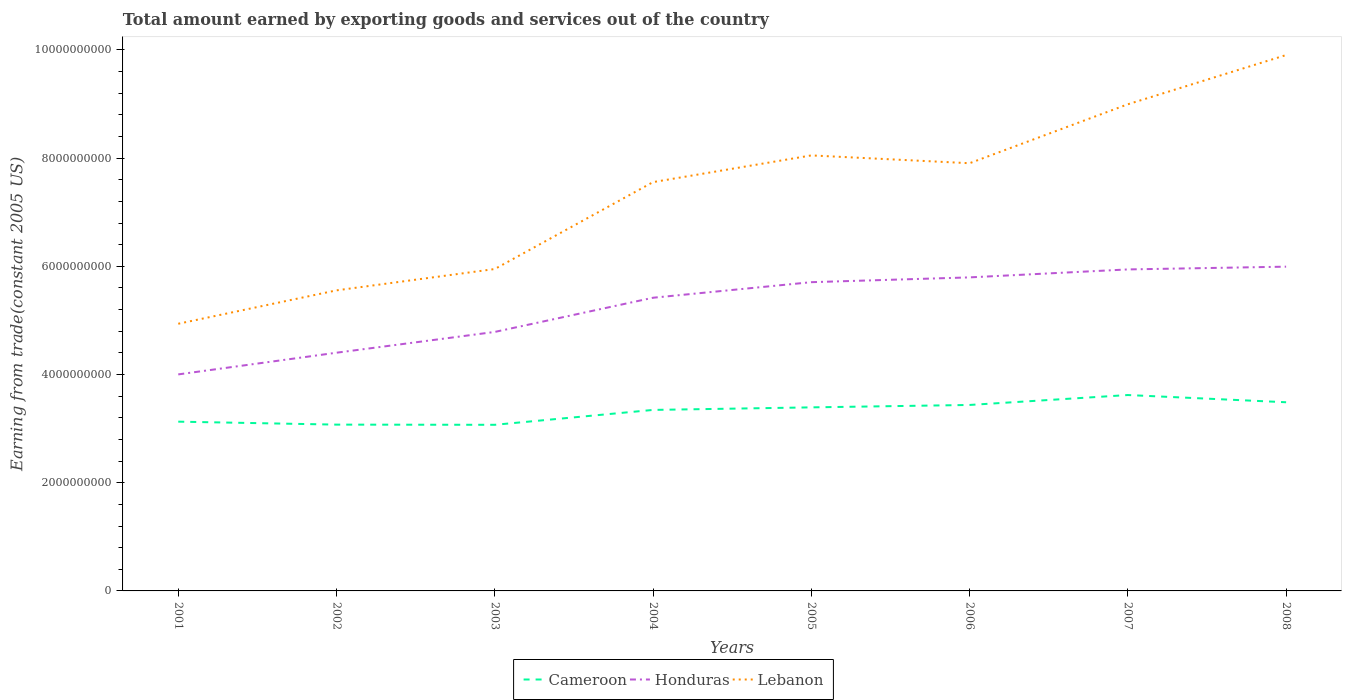Does the line corresponding to Honduras intersect with the line corresponding to Cameroon?
Your answer should be compact. No. Is the number of lines equal to the number of legend labels?
Give a very brief answer. Yes. Across all years, what is the maximum total amount earned by exporting goods and services in Cameroon?
Provide a short and direct response. 3.07e+09. What is the total total amount earned by exporting goods and services in Cameroon in the graph?
Your answer should be compact. -5.47e+08. What is the difference between the highest and the second highest total amount earned by exporting goods and services in Lebanon?
Provide a succinct answer. 4.97e+09. What is the difference between the highest and the lowest total amount earned by exporting goods and services in Honduras?
Offer a terse response. 5. Is the total amount earned by exporting goods and services in Lebanon strictly greater than the total amount earned by exporting goods and services in Honduras over the years?
Ensure brevity in your answer.  No. How many lines are there?
Offer a very short reply. 3. How many years are there in the graph?
Your answer should be compact. 8. Where does the legend appear in the graph?
Your answer should be compact. Bottom center. How are the legend labels stacked?
Your response must be concise. Horizontal. What is the title of the graph?
Provide a short and direct response. Total amount earned by exporting goods and services out of the country. What is the label or title of the X-axis?
Your answer should be compact. Years. What is the label or title of the Y-axis?
Make the answer very short. Earning from trade(constant 2005 US). What is the Earning from trade(constant 2005 US) in Cameroon in 2001?
Offer a terse response. 3.13e+09. What is the Earning from trade(constant 2005 US) of Honduras in 2001?
Keep it short and to the point. 4.00e+09. What is the Earning from trade(constant 2005 US) in Lebanon in 2001?
Ensure brevity in your answer.  4.94e+09. What is the Earning from trade(constant 2005 US) in Cameroon in 2002?
Your response must be concise. 3.07e+09. What is the Earning from trade(constant 2005 US) of Honduras in 2002?
Make the answer very short. 4.40e+09. What is the Earning from trade(constant 2005 US) in Lebanon in 2002?
Offer a very short reply. 5.56e+09. What is the Earning from trade(constant 2005 US) of Cameroon in 2003?
Your response must be concise. 3.07e+09. What is the Earning from trade(constant 2005 US) in Honduras in 2003?
Provide a short and direct response. 4.79e+09. What is the Earning from trade(constant 2005 US) of Lebanon in 2003?
Your response must be concise. 5.95e+09. What is the Earning from trade(constant 2005 US) of Cameroon in 2004?
Provide a short and direct response. 3.35e+09. What is the Earning from trade(constant 2005 US) of Honduras in 2004?
Your answer should be very brief. 5.42e+09. What is the Earning from trade(constant 2005 US) in Lebanon in 2004?
Your answer should be very brief. 7.56e+09. What is the Earning from trade(constant 2005 US) of Cameroon in 2005?
Ensure brevity in your answer.  3.39e+09. What is the Earning from trade(constant 2005 US) of Honduras in 2005?
Offer a terse response. 5.71e+09. What is the Earning from trade(constant 2005 US) in Lebanon in 2005?
Provide a short and direct response. 8.05e+09. What is the Earning from trade(constant 2005 US) in Cameroon in 2006?
Make the answer very short. 3.44e+09. What is the Earning from trade(constant 2005 US) of Honduras in 2006?
Ensure brevity in your answer.  5.80e+09. What is the Earning from trade(constant 2005 US) of Lebanon in 2006?
Give a very brief answer. 7.91e+09. What is the Earning from trade(constant 2005 US) of Cameroon in 2007?
Provide a succinct answer. 3.62e+09. What is the Earning from trade(constant 2005 US) in Honduras in 2007?
Your answer should be very brief. 5.94e+09. What is the Earning from trade(constant 2005 US) in Lebanon in 2007?
Your answer should be compact. 9.00e+09. What is the Earning from trade(constant 2005 US) of Cameroon in 2008?
Your answer should be compact. 3.49e+09. What is the Earning from trade(constant 2005 US) in Honduras in 2008?
Ensure brevity in your answer.  5.99e+09. What is the Earning from trade(constant 2005 US) of Lebanon in 2008?
Your answer should be compact. 9.91e+09. Across all years, what is the maximum Earning from trade(constant 2005 US) of Cameroon?
Provide a succinct answer. 3.62e+09. Across all years, what is the maximum Earning from trade(constant 2005 US) of Honduras?
Your response must be concise. 5.99e+09. Across all years, what is the maximum Earning from trade(constant 2005 US) of Lebanon?
Offer a terse response. 9.91e+09. Across all years, what is the minimum Earning from trade(constant 2005 US) in Cameroon?
Your answer should be very brief. 3.07e+09. Across all years, what is the minimum Earning from trade(constant 2005 US) in Honduras?
Your response must be concise. 4.00e+09. Across all years, what is the minimum Earning from trade(constant 2005 US) of Lebanon?
Offer a very short reply. 4.94e+09. What is the total Earning from trade(constant 2005 US) of Cameroon in the graph?
Provide a succinct answer. 2.66e+1. What is the total Earning from trade(constant 2005 US) in Honduras in the graph?
Offer a terse response. 4.21e+1. What is the total Earning from trade(constant 2005 US) in Lebanon in the graph?
Your answer should be compact. 5.89e+1. What is the difference between the Earning from trade(constant 2005 US) of Cameroon in 2001 and that in 2002?
Provide a succinct answer. 5.49e+07. What is the difference between the Earning from trade(constant 2005 US) in Honduras in 2001 and that in 2002?
Keep it short and to the point. -4.01e+08. What is the difference between the Earning from trade(constant 2005 US) in Lebanon in 2001 and that in 2002?
Offer a very short reply. -6.17e+08. What is the difference between the Earning from trade(constant 2005 US) of Cameroon in 2001 and that in 2003?
Your answer should be very brief. 5.82e+07. What is the difference between the Earning from trade(constant 2005 US) in Honduras in 2001 and that in 2003?
Your answer should be very brief. -7.85e+08. What is the difference between the Earning from trade(constant 2005 US) of Lebanon in 2001 and that in 2003?
Your answer should be very brief. -1.01e+09. What is the difference between the Earning from trade(constant 2005 US) in Cameroon in 2001 and that in 2004?
Provide a short and direct response. -2.17e+08. What is the difference between the Earning from trade(constant 2005 US) of Honduras in 2001 and that in 2004?
Your response must be concise. -1.42e+09. What is the difference between the Earning from trade(constant 2005 US) of Lebanon in 2001 and that in 2004?
Your response must be concise. -2.62e+09. What is the difference between the Earning from trade(constant 2005 US) of Cameroon in 2001 and that in 2005?
Provide a short and direct response. -2.64e+08. What is the difference between the Earning from trade(constant 2005 US) in Honduras in 2001 and that in 2005?
Ensure brevity in your answer.  -1.70e+09. What is the difference between the Earning from trade(constant 2005 US) in Lebanon in 2001 and that in 2005?
Keep it short and to the point. -3.11e+09. What is the difference between the Earning from trade(constant 2005 US) in Cameroon in 2001 and that in 2006?
Your response must be concise. -3.09e+08. What is the difference between the Earning from trade(constant 2005 US) in Honduras in 2001 and that in 2006?
Keep it short and to the point. -1.79e+09. What is the difference between the Earning from trade(constant 2005 US) of Lebanon in 2001 and that in 2006?
Give a very brief answer. -2.97e+09. What is the difference between the Earning from trade(constant 2005 US) in Cameroon in 2001 and that in 2007?
Your answer should be compact. -4.92e+08. What is the difference between the Earning from trade(constant 2005 US) in Honduras in 2001 and that in 2007?
Make the answer very short. -1.94e+09. What is the difference between the Earning from trade(constant 2005 US) of Lebanon in 2001 and that in 2007?
Offer a terse response. -4.06e+09. What is the difference between the Earning from trade(constant 2005 US) in Cameroon in 2001 and that in 2008?
Keep it short and to the point. -3.59e+08. What is the difference between the Earning from trade(constant 2005 US) in Honduras in 2001 and that in 2008?
Your answer should be very brief. -1.99e+09. What is the difference between the Earning from trade(constant 2005 US) of Lebanon in 2001 and that in 2008?
Provide a short and direct response. -4.97e+09. What is the difference between the Earning from trade(constant 2005 US) in Cameroon in 2002 and that in 2003?
Ensure brevity in your answer.  3.32e+06. What is the difference between the Earning from trade(constant 2005 US) in Honduras in 2002 and that in 2003?
Give a very brief answer. -3.84e+08. What is the difference between the Earning from trade(constant 2005 US) of Lebanon in 2002 and that in 2003?
Your response must be concise. -3.94e+08. What is the difference between the Earning from trade(constant 2005 US) of Cameroon in 2002 and that in 2004?
Provide a short and direct response. -2.72e+08. What is the difference between the Earning from trade(constant 2005 US) of Honduras in 2002 and that in 2004?
Your response must be concise. -1.02e+09. What is the difference between the Earning from trade(constant 2005 US) in Lebanon in 2002 and that in 2004?
Keep it short and to the point. -2.00e+09. What is the difference between the Earning from trade(constant 2005 US) in Cameroon in 2002 and that in 2005?
Make the answer very short. -3.19e+08. What is the difference between the Earning from trade(constant 2005 US) in Honduras in 2002 and that in 2005?
Keep it short and to the point. -1.30e+09. What is the difference between the Earning from trade(constant 2005 US) in Lebanon in 2002 and that in 2005?
Ensure brevity in your answer.  -2.49e+09. What is the difference between the Earning from trade(constant 2005 US) of Cameroon in 2002 and that in 2006?
Give a very brief answer. -3.63e+08. What is the difference between the Earning from trade(constant 2005 US) of Honduras in 2002 and that in 2006?
Offer a very short reply. -1.39e+09. What is the difference between the Earning from trade(constant 2005 US) in Lebanon in 2002 and that in 2006?
Your response must be concise. -2.35e+09. What is the difference between the Earning from trade(constant 2005 US) in Cameroon in 2002 and that in 2007?
Your response must be concise. -5.47e+08. What is the difference between the Earning from trade(constant 2005 US) in Honduras in 2002 and that in 2007?
Your response must be concise. -1.54e+09. What is the difference between the Earning from trade(constant 2005 US) in Lebanon in 2002 and that in 2007?
Provide a short and direct response. -3.44e+09. What is the difference between the Earning from trade(constant 2005 US) of Cameroon in 2002 and that in 2008?
Offer a very short reply. -4.13e+08. What is the difference between the Earning from trade(constant 2005 US) of Honduras in 2002 and that in 2008?
Your answer should be very brief. -1.59e+09. What is the difference between the Earning from trade(constant 2005 US) of Lebanon in 2002 and that in 2008?
Make the answer very short. -4.35e+09. What is the difference between the Earning from trade(constant 2005 US) in Cameroon in 2003 and that in 2004?
Your answer should be compact. -2.75e+08. What is the difference between the Earning from trade(constant 2005 US) of Honduras in 2003 and that in 2004?
Ensure brevity in your answer.  -6.32e+08. What is the difference between the Earning from trade(constant 2005 US) in Lebanon in 2003 and that in 2004?
Your answer should be very brief. -1.61e+09. What is the difference between the Earning from trade(constant 2005 US) in Cameroon in 2003 and that in 2005?
Provide a succinct answer. -3.22e+08. What is the difference between the Earning from trade(constant 2005 US) in Honduras in 2003 and that in 2005?
Offer a terse response. -9.20e+08. What is the difference between the Earning from trade(constant 2005 US) in Lebanon in 2003 and that in 2005?
Offer a very short reply. -2.10e+09. What is the difference between the Earning from trade(constant 2005 US) in Cameroon in 2003 and that in 2006?
Your answer should be very brief. -3.67e+08. What is the difference between the Earning from trade(constant 2005 US) of Honduras in 2003 and that in 2006?
Offer a terse response. -1.01e+09. What is the difference between the Earning from trade(constant 2005 US) in Lebanon in 2003 and that in 2006?
Provide a short and direct response. -1.96e+09. What is the difference between the Earning from trade(constant 2005 US) in Cameroon in 2003 and that in 2007?
Make the answer very short. -5.50e+08. What is the difference between the Earning from trade(constant 2005 US) in Honduras in 2003 and that in 2007?
Offer a very short reply. -1.16e+09. What is the difference between the Earning from trade(constant 2005 US) in Lebanon in 2003 and that in 2007?
Provide a succinct answer. -3.05e+09. What is the difference between the Earning from trade(constant 2005 US) in Cameroon in 2003 and that in 2008?
Make the answer very short. -4.17e+08. What is the difference between the Earning from trade(constant 2005 US) of Honduras in 2003 and that in 2008?
Provide a succinct answer. -1.21e+09. What is the difference between the Earning from trade(constant 2005 US) of Lebanon in 2003 and that in 2008?
Provide a short and direct response. -3.95e+09. What is the difference between the Earning from trade(constant 2005 US) of Cameroon in 2004 and that in 2005?
Provide a short and direct response. -4.72e+07. What is the difference between the Earning from trade(constant 2005 US) of Honduras in 2004 and that in 2005?
Make the answer very short. -2.88e+08. What is the difference between the Earning from trade(constant 2005 US) of Lebanon in 2004 and that in 2005?
Offer a very short reply. -4.93e+08. What is the difference between the Earning from trade(constant 2005 US) of Cameroon in 2004 and that in 2006?
Provide a succinct answer. -9.17e+07. What is the difference between the Earning from trade(constant 2005 US) in Honduras in 2004 and that in 2006?
Make the answer very short. -3.76e+08. What is the difference between the Earning from trade(constant 2005 US) of Lebanon in 2004 and that in 2006?
Provide a short and direct response. -3.49e+08. What is the difference between the Earning from trade(constant 2005 US) in Cameroon in 2004 and that in 2007?
Your response must be concise. -2.75e+08. What is the difference between the Earning from trade(constant 2005 US) in Honduras in 2004 and that in 2007?
Give a very brief answer. -5.23e+08. What is the difference between the Earning from trade(constant 2005 US) of Lebanon in 2004 and that in 2007?
Make the answer very short. -1.44e+09. What is the difference between the Earning from trade(constant 2005 US) in Cameroon in 2004 and that in 2008?
Offer a terse response. -1.42e+08. What is the difference between the Earning from trade(constant 2005 US) of Honduras in 2004 and that in 2008?
Ensure brevity in your answer.  -5.74e+08. What is the difference between the Earning from trade(constant 2005 US) in Lebanon in 2004 and that in 2008?
Provide a short and direct response. -2.35e+09. What is the difference between the Earning from trade(constant 2005 US) in Cameroon in 2005 and that in 2006?
Ensure brevity in your answer.  -4.46e+07. What is the difference between the Earning from trade(constant 2005 US) of Honduras in 2005 and that in 2006?
Ensure brevity in your answer.  -8.87e+07. What is the difference between the Earning from trade(constant 2005 US) in Lebanon in 2005 and that in 2006?
Offer a very short reply. 1.44e+08. What is the difference between the Earning from trade(constant 2005 US) of Cameroon in 2005 and that in 2007?
Offer a very short reply. -2.28e+08. What is the difference between the Earning from trade(constant 2005 US) in Honduras in 2005 and that in 2007?
Keep it short and to the point. -2.36e+08. What is the difference between the Earning from trade(constant 2005 US) in Lebanon in 2005 and that in 2007?
Make the answer very short. -9.45e+08. What is the difference between the Earning from trade(constant 2005 US) of Cameroon in 2005 and that in 2008?
Your response must be concise. -9.45e+07. What is the difference between the Earning from trade(constant 2005 US) of Honduras in 2005 and that in 2008?
Make the answer very short. -2.87e+08. What is the difference between the Earning from trade(constant 2005 US) of Lebanon in 2005 and that in 2008?
Make the answer very short. -1.85e+09. What is the difference between the Earning from trade(constant 2005 US) in Cameroon in 2006 and that in 2007?
Your answer should be compact. -1.84e+08. What is the difference between the Earning from trade(constant 2005 US) of Honduras in 2006 and that in 2007?
Your response must be concise. -1.47e+08. What is the difference between the Earning from trade(constant 2005 US) of Lebanon in 2006 and that in 2007?
Give a very brief answer. -1.09e+09. What is the difference between the Earning from trade(constant 2005 US) of Cameroon in 2006 and that in 2008?
Your answer should be compact. -4.99e+07. What is the difference between the Earning from trade(constant 2005 US) of Honduras in 2006 and that in 2008?
Provide a short and direct response. -1.98e+08. What is the difference between the Earning from trade(constant 2005 US) of Lebanon in 2006 and that in 2008?
Provide a short and direct response. -2.00e+09. What is the difference between the Earning from trade(constant 2005 US) in Cameroon in 2007 and that in 2008?
Your response must be concise. 1.34e+08. What is the difference between the Earning from trade(constant 2005 US) in Honduras in 2007 and that in 2008?
Provide a succinct answer. -5.11e+07. What is the difference between the Earning from trade(constant 2005 US) of Lebanon in 2007 and that in 2008?
Offer a very short reply. -9.10e+08. What is the difference between the Earning from trade(constant 2005 US) in Cameroon in 2001 and the Earning from trade(constant 2005 US) in Honduras in 2002?
Provide a succinct answer. -1.27e+09. What is the difference between the Earning from trade(constant 2005 US) in Cameroon in 2001 and the Earning from trade(constant 2005 US) in Lebanon in 2002?
Keep it short and to the point. -2.43e+09. What is the difference between the Earning from trade(constant 2005 US) in Honduras in 2001 and the Earning from trade(constant 2005 US) in Lebanon in 2002?
Your answer should be very brief. -1.55e+09. What is the difference between the Earning from trade(constant 2005 US) in Cameroon in 2001 and the Earning from trade(constant 2005 US) in Honduras in 2003?
Your answer should be compact. -1.66e+09. What is the difference between the Earning from trade(constant 2005 US) in Cameroon in 2001 and the Earning from trade(constant 2005 US) in Lebanon in 2003?
Offer a terse response. -2.82e+09. What is the difference between the Earning from trade(constant 2005 US) in Honduras in 2001 and the Earning from trade(constant 2005 US) in Lebanon in 2003?
Offer a very short reply. -1.95e+09. What is the difference between the Earning from trade(constant 2005 US) in Cameroon in 2001 and the Earning from trade(constant 2005 US) in Honduras in 2004?
Your answer should be very brief. -2.29e+09. What is the difference between the Earning from trade(constant 2005 US) of Cameroon in 2001 and the Earning from trade(constant 2005 US) of Lebanon in 2004?
Your answer should be compact. -4.43e+09. What is the difference between the Earning from trade(constant 2005 US) of Honduras in 2001 and the Earning from trade(constant 2005 US) of Lebanon in 2004?
Ensure brevity in your answer.  -3.55e+09. What is the difference between the Earning from trade(constant 2005 US) in Cameroon in 2001 and the Earning from trade(constant 2005 US) in Honduras in 2005?
Keep it short and to the point. -2.58e+09. What is the difference between the Earning from trade(constant 2005 US) of Cameroon in 2001 and the Earning from trade(constant 2005 US) of Lebanon in 2005?
Provide a short and direct response. -4.92e+09. What is the difference between the Earning from trade(constant 2005 US) of Honduras in 2001 and the Earning from trade(constant 2005 US) of Lebanon in 2005?
Your answer should be compact. -4.05e+09. What is the difference between the Earning from trade(constant 2005 US) of Cameroon in 2001 and the Earning from trade(constant 2005 US) of Honduras in 2006?
Give a very brief answer. -2.67e+09. What is the difference between the Earning from trade(constant 2005 US) in Cameroon in 2001 and the Earning from trade(constant 2005 US) in Lebanon in 2006?
Your response must be concise. -4.78e+09. What is the difference between the Earning from trade(constant 2005 US) of Honduras in 2001 and the Earning from trade(constant 2005 US) of Lebanon in 2006?
Your answer should be very brief. -3.90e+09. What is the difference between the Earning from trade(constant 2005 US) of Cameroon in 2001 and the Earning from trade(constant 2005 US) of Honduras in 2007?
Keep it short and to the point. -2.81e+09. What is the difference between the Earning from trade(constant 2005 US) in Cameroon in 2001 and the Earning from trade(constant 2005 US) in Lebanon in 2007?
Your answer should be very brief. -5.87e+09. What is the difference between the Earning from trade(constant 2005 US) of Honduras in 2001 and the Earning from trade(constant 2005 US) of Lebanon in 2007?
Your answer should be very brief. -4.99e+09. What is the difference between the Earning from trade(constant 2005 US) in Cameroon in 2001 and the Earning from trade(constant 2005 US) in Honduras in 2008?
Your answer should be very brief. -2.86e+09. What is the difference between the Earning from trade(constant 2005 US) of Cameroon in 2001 and the Earning from trade(constant 2005 US) of Lebanon in 2008?
Give a very brief answer. -6.78e+09. What is the difference between the Earning from trade(constant 2005 US) in Honduras in 2001 and the Earning from trade(constant 2005 US) in Lebanon in 2008?
Give a very brief answer. -5.90e+09. What is the difference between the Earning from trade(constant 2005 US) of Cameroon in 2002 and the Earning from trade(constant 2005 US) of Honduras in 2003?
Keep it short and to the point. -1.71e+09. What is the difference between the Earning from trade(constant 2005 US) of Cameroon in 2002 and the Earning from trade(constant 2005 US) of Lebanon in 2003?
Offer a terse response. -2.88e+09. What is the difference between the Earning from trade(constant 2005 US) in Honduras in 2002 and the Earning from trade(constant 2005 US) in Lebanon in 2003?
Your answer should be very brief. -1.55e+09. What is the difference between the Earning from trade(constant 2005 US) in Cameroon in 2002 and the Earning from trade(constant 2005 US) in Honduras in 2004?
Ensure brevity in your answer.  -2.35e+09. What is the difference between the Earning from trade(constant 2005 US) of Cameroon in 2002 and the Earning from trade(constant 2005 US) of Lebanon in 2004?
Provide a short and direct response. -4.48e+09. What is the difference between the Earning from trade(constant 2005 US) in Honduras in 2002 and the Earning from trade(constant 2005 US) in Lebanon in 2004?
Offer a very short reply. -3.15e+09. What is the difference between the Earning from trade(constant 2005 US) in Cameroon in 2002 and the Earning from trade(constant 2005 US) in Honduras in 2005?
Offer a terse response. -2.63e+09. What is the difference between the Earning from trade(constant 2005 US) in Cameroon in 2002 and the Earning from trade(constant 2005 US) in Lebanon in 2005?
Ensure brevity in your answer.  -4.98e+09. What is the difference between the Earning from trade(constant 2005 US) in Honduras in 2002 and the Earning from trade(constant 2005 US) in Lebanon in 2005?
Your answer should be compact. -3.65e+09. What is the difference between the Earning from trade(constant 2005 US) in Cameroon in 2002 and the Earning from trade(constant 2005 US) in Honduras in 2006?
Give a very brief answer. -2.72e+09. What is the difference between the Earning from trade(constant 2005 US) in Cameroon in 2002 and the Earning from trade(constant 2005 US) in Lebanon in 2006?
Offer a terse response. -4.83e+09. What is the difference between the Earning from trade(constant 2005 US) of Honduras in 2002 and the Earning from trade(constant 2005 US) of Lebanon in 2006?
Ensure brevity in your answer.  -3.50e+09. What is the difference between the Earning from trade(constant 2005 US) in Cameroon in 2002 and the Earning from trade(constant 2005 US) in Honduras in 2007?
Your response must be concise. -2.87e+09. What is the difference between the Earning from trade(constant 2005 US) of Cameroon in 2002 and the Earning from trade(constant 2005 US) of Lebanon in 2007?
Keep it short and to the point. -5.92e+09. What is the difference between the Earning from trade(constant 2005 US) in Honduras in 2002 and the Earning from trade(constant 2005 US) in Lebanon in 2007?
Provide a short and direct response. -4.59e+09. What is the difference between the Earning from trade(constant 2005 US) in Cameroon in 2002 and the Earning from trade(constant 2005 US) in Honduras in 2008?
Give a very brief answer. -2.92e+09. What is the difference between the Earning from trade(constant 2005 US) of Cameroon in 2002 and the Earning from trade(constant 2005 US) of Lebanon in 2008?
Make the answer very short. -6.83e+09. What is the difference between the Earning from trade(constant 2005 US) in Honduras in 2002 and the Earning from trade(constant 2005 US) in Lebanon in 2008?
Your answer should be very brief. -5.50e+09. What is the difference between the Earning from trade(constant 2005 US) of Cameroon in 2003 and the Earning from trade(constant 2005 US) of Honduras in 2004?
Offer a terse response. -2.35e+09. What is the difference between the Earning from trade(constant 2005 US) in Cameroon in 2003 and the Earning from trade(constant 2005 US) in Lebanon in 2004?
Make the answer very short. -4.49e+09. What is the difference between the Earning from trade(constant 2005 US) of Honduras in 2003 and the Earning from trade(constant 2005 US) of Lebanon in 2004?
Your answer should be compact. -2.77e+09. What is the difference between the Earning from trade(constant 2005 US) in Cameroon in 2003 and the Earning from trade(constant 2005 US) in Honduras in 2005?
Ensure brevity in your answer.  -2.64e+09. What is the difference between the Earning from trade(constant 2005 US) in Cameroon in 2003 and the Earning from trade(constant 2005 US) in Lebanon in 2005?
Offer a very short reply. -4.98e+09. What is the difference between the Earning from trade(constant 2005 US) of Honduras in 2003 and the Earning from trade(constant 2005 US) of Lebanon in 2005?
Offer a very short reply. -3.26e+09. What is the difference between the Earning from trade(constant 2005 US) of Cameroon in 2003 and the Earning from trade(constant 2005 US) of Honduras in 2006?
Your answer should be compact. -2.73e+09. What is the difference between the Earning from trade(constant 2005 US) of Cameroon in 2003 and the Earning from trade(constant 2005 US) of Lebanon in 2006?
Your response must be concise. -4.84e+09. What is the difference between the Earning from trade(constant 2005 US) in Honduras in 2003 and the Earning from trade(constant 2005 US) in Lebanon in 2006?
Your answer should be very brief. -3.12e+09. What is the difference between the Earning from trade(constant 2005 US) of Cameroon in 2003 and the Earning from trade(constant 2005 US) of Honduras in 2007?
Ensure brevity in your answer.  -2.87e+09. What is the difference between the Earning from trade(constant 2005 US) in Cameroon in 2003 and the Earning from trade(constant 2005 US) in Lebanon in 2007?
Offer a terse response. -5.92e+09. What is the difference between the Earning from trade(constant 2005 US) of Honduras in 2003 and the Earning from trade(constant 2005 US) of Lebanon in 2007?
Provide a succinct answer. -4.21e+09. What is the difference between the Earning from trade(constant 2005 US) of Cameroon in 2003 and the Earning from trade(constant 2005 US) of Honduras in 2008?
Keep it short and to the point. -2.92e+09. What is the difference between the Earning from trade(constant 2005 US) in Cameroon in 2003 and the Earning from trade(constant 2005 US) in Lebanon in 2008?
Offer a very short reply. -6.83e+09. What is the difference between the Earning from trade(constant 2005 US) of Honduras in 2003 and the Earning from trade(constant 2005 US) of Lebanon in 2008?
Provide a short and direct response. -5.12e+09. What is the difference between the Earning from trade(constant 2005 US) of Cameroon in 2004 and the Earning from trade(constant 2005 US) of Honduras in 2005?
Offer a very short reply. -2.36e+09. What is the difference between the Earning from trade(constant 2005 US) of Cameroon in 2004 and the Earning from trade(constant 2005 US) of Lebanon in 2005?
Offer a terse response. -4.70e+09. What is the difference between the Earning from trade(constant 2005 US) in Honduras in 2004 and the Earning from trade(constant 2005 US) in Lebanon in 2005?
Ensure brevity in your answer.  -2.63e+09. What is the difference between the Earning from trade(constant 2005 US) of Cameroon in 2004 and the Earning from trade(constant 2005 US) of Honduras in 2006?
Provide a short and direct response. -2.45e+09. What is the difference between the Earning from trade(constant 2005 US) of Cameroon in 2004 and the Earning from trade(constant 2005 US) of Lebanon in 2006?
Your answer should be very brief. -4.56e+09. What is the difference between the Earning from trade(constant 2005 US) in Honduras in 2004 and the Earning from trade(constant 2005 US) in Lebanon in 2006?
Your answer should be compact. -2.49e+09. What is the difference between the Earning from trade(constant 2005 US) in Cameroon in 2004 and the Earning from trade(constant 2005 US) in Honduras in 2007?
Keep it short and to the point. -2.60e+09. What is the difference between the Earning from trade(constant 2005 US) of Cameroon in 2004 and the Earning from trade(constant 2005 US) of Lebanon in 2007?
Provide a short and direct response. -5.65e+09. What is the difference between the Earning from trade(constant 2005 US) of Honduras in 2004 and the Earning from trade(constant 2005 US) of Lebanon in 2007?
Provide a succinct answer. -3.58e+09. What is the difference between the Earning from trade(constant 2005 US) in Cameroon in 2004 and the Earning from trade(constant 2005 US) in Honduras in 2008?
Provide a short and direct response. -2.65e+09. What is the difference between the Earning from trade(constant 2005 US) in Cameroon in 2004 and the Earning from trade(constant 2005 US) in Lebanon in 2008?
Your response must be concise. -6.56e+09. What is the difference between the Earning from trade(constant 2005 US) of Honduras in 2004 and the Earning from trade(constant 2005 US) of Lebanon in 2008?
Your response must be concise. -4.49e+09. What is the difference between the Earning from trade(constant 2005 US) in Cameroon in 2005 and the Earning from trade(constant 2005 US) in Honduras in 2006?
Offer a terse response. -2.40e+09. What is the difference between the Earning from trade(constant 2005 US) in Cameroon in 2005 and the Earning from trade(constant 2005 US) in Lebanon in 2006?
Your response must be concise. -4.51e+09. What is the difference between the Earning from trade(constant 2005 US) in Honduras in 2005 and the Earning from trade(constant 2005 US) in Lebanon in 2006?
Provide a succinct answer. -2.20e+09. What is the difference between the Earning from trade(constant 2005 US) in Cameroon in 2005 and the Earning from trade(constant 2005 US) in Honduras in 2007?
Provide a short and direct response. -2.55e+09. What is the difference between the Earning from trade(constant 2005 US) of Cameroon in 2005 and the Earning from trade(constant 2005 US) of Lebanon in 2007?
Your response must be concise. -5.60e+09. What is the difference between the Earning from trade(constant 2005 US) of Honduras in 2005 and the Earning from trade(constant 2005 US) of Lebanon in 2007?
Give a very brief answer. -3.29e+09. What is the difference between the Earning from trade(constant 2005 US) of Cameroon in 2005 and the Earning from trade(constant 2005 US) of Honduras in 2008?
Keep it short and to the point. -2.60e+09. What is the difference between the Earning from trade(constant 2005 US) of Cameroon in 2005 and the Earning from trade(constant 2005 US) of Lebanon in 2008?
Provide a succinct answer. -6.51e+09. What is the difference between the Earning from trade(constant 2005 US) of Honduras in 2005 and the Earning from trade(constant 2005 US) of Lebanon in 2008?
Offer a very short reply. -4.20e+09. What is the difference between the Earning from trade(constant 2005 US) in Cameroon in 2006 and the Earning from trade(constant 2005 US) in Honduras in 2007?
Offer a very short reply. -2.51e+09. What is the difference between the Earning from trade(constant 2005 US) of Cameroon in 2006 and the Earning from trade(constant 2005 US) of Lebanon in 2007?
Your answer should be compact. -5.56e+09. What is the difference between the Earning from trade(constant 2005 US) in Honduras in 2006 and the Earning from trade(constant 2005 US) in Lebanon in 2007?
Make the answer very short. -3.20e+09. What is the difference between the Earning from trade(constant 2005 US) in Cameroon in 2006 and the Earning from trade(constant 2005 US) in Honduras in 2008?
Offer a very short reply. -2.56e+09. What is the difference between the Earning from trade(constant 2005 US) of Cameroon in 2006 and the Earning from trade(constant 2005 US) of Lebanon in 2008?
Ensure brevity in your answer.  -6.47e+09. What is the difference between the Earning from trade(constant 2005 US) of Honduras in 2006 and the Earning from trade(constant 2005 US) of Lebanon in 2008?
Your response must be concise. -4.11e+09. What is the difference between the Earning from trade(constant 2005 US) in Cameroon in 2007 and the Earning from trade(constant 2005 US) in Honduras in 2008?
Your answer should be compact. -2.37e+09. What is the difference between the Earning from trade(constant 2005 US) in Cameroon in 2007 and the Earning from trade(constant 2005 US) in Lebanon in 2008?
Provide a succinct answer. -6.28e+09. What is the difference between the Earning from trade(constant 2005 US) in Honduras in 2007 and the Earning from trade(constant 2005 US) in Lebanon in 2008?
Make the answer very short. -3.96e+09. What is the average Earning from trade(constant 2005 US) in Cameroon per year?
Offer a very short reply. 3.32e+09. What is the average Earning from trade(constant 2005 US) in Honduras per year?
Your response must be concise. 5.26e+09. What is the average Earning from trade(constant 2005 US) in Lebanon per year?
Make the answer very short. 7.36e+09. In the year 2001, what is the difference between the Earning from trade(constant 2005 US) of Cameroon and Earning from trade(constant 2005 US) of Honduras?
Provide a short and direct response. -8.74e+08. In the year 2001, what is the difference between the Earning from trade(constant 2005 US) in Cameroon and Earning from trade(constant 2005 US) in Lebanon?
Offer a terse response. -1.81e+09. In the year 2001, what is the difference between the Earning from trade(constant 2005 US) in Honduras and Earning from trade(constant 2005 US) in Lebanon?
Your answer should be compact. -9.36e+08. In the year 2002, what is the difference between the Earning from trade(constant 2005 US) in Cameroon and Earning from trade(constant 2005 US) in Honduras?
Your answer should be compact. -1.33e+09. In the year 2002, what is the difference between the Earning from trade(constant 2005 US) in Cameroon and Earning from trade(constant 2005 US) in Lebanon?
Make the answer very short. -2.48e+09. In the year 2002, what is the difference between the Earning from trade(constant 2005 US) of Honduras and Earning from trade(constant 2005 US) of Lebanon?
Your response must be concise. -1.15e+09. In the year 2003, what is the difference between the Earning from trade(constant 2005 US) of Cameroon and Earning from trade(constant 2005 US) of Honduras?
Offer a terse response. -1.72e+09. In the year 2003, what is the difference between the Earning from trade(constant 2005 US) in Cameroon and Earning from trade(constant 2005 US) in Lebanon?
Keep it short and to the point. -2.88e+09. In the year 2003, what is the difference between the Earning from trade(constant 2005 US) of Honduras and Earning from trade(constant 2005 US) of Lebanon?
Keep it short and to the point. -1.16e+09. In the year 2004, what is the difference between the Earning from trade(constant 2005 US) in Cameroon and Earning from trade(constant 2005 US) in Honduras?
Your response must be concise. -2.07e+09. In the year 2004, what is the difference between the Earning from trade(constant 2005 US) of Cameroon and Earning from trade(constant 2005 US) of Lebanon?
Offer a very short reply. -4.21e+09. In the year 2004, what is the difference between the Earning from trade(constant 2005 US) in Honduras and Earning from trade(constant 2005 US) in Lebanon?
Make the answer very short. -2.14e+09. In the year 2005, what is the difference between the Earning from trade(constant 2005 US) of Cameroon and Earning from trade(constant 2005 US) of Honduras?
Keep it short and to the point. -2.31e+09. In the year 2005, what is the difference between the Earning from trade(constant 2005 US) of Cameroon and Earning from trade(constant 2005 US) of Lebanon?
Ensure brevity in your answer.  -4.66e+09. In the year 2005, what is the difference between the Earning from trade(constant 2005 US) in Honduras and Earning from trade(constant 2005 US) in Lebanon?
Your answer should be very brief. -2.34e+09. In the year 2006, what is the difference between the Earning from trade(constant 2005 US) of Cameroon and Earning from trade(constant 2005 US) of Honduras?
Provide a short and direct response. -2.36e+09. In the year 2006, what is the difference between the Earning from trade(constant 2005 US) of Cameroon and Earning from trade(constant 2005 US) of Lebanon?
Your response must be concise. -4.47e+09. In the year 2006, what is the difference between the Earning from trade(constant 2005 US) in Honduras and Earning from trade(constant 2005 US) in Lebanon?
Offer a very short reply. -2.11e+09. In the year 2007, what is the difference between the Earning from trade(constant 2005 US) in Cameroon and Earning from trade(constant 2005 US) in Honduras?
Make the answer very short. -2.32e+09. In the year 2007, what is the difference between the Earning from trade(constant 2005 US) of Cameroon and Earning from trade(constant 2005 US) of Lebanon?
Make the answer very short. -5.37e+09. In the year 2007, what is the difference between the Earning from trade(constant 2005 US) of Honduras and Earning from trade(constant 2005 US) of Lebanon?
Offer a very short reply. -3.05e+09. In the year 2008, what is the difference between the Earning from trade(constant 2005 US) of Cameroon and Earning from trade(constant 2005 US) of Honduras?
Provide a succinct answer. -2.51e+09. In the year 2008, what is the difference between the Earning from trade(constant 2005 US) of Cameroon and Earning from trade(constant 2005 US) of Lebanon?
Ensure brevity in your answer.  -6.42e+09. In the year 2008, what is the difference between the Earning from trade(constant 2005 US) in Honduras and Earning from trade(constant 2005 US) in Lebanon?
Offer a terse response. -3.91e+09. What is the ratio of the Earning from trade(constant 2005 US) of Cameroon in 2001 to that in 2002?
Ensure brevity in your answer.  1.02. What is the ratio of the Earning from trade(constant 2005 US) of Honduras in 2001 to that in 2002?
Your answer should be very brief. 0.91. What is the ratio of the Earning from trade(constant 2005 US) of Lebanon in 2001 to that in 2002?
Ensure brevity in your answer.  0.89. What is the ratio of the Earning from trade(constant 2005 US) in Cameroon in 2001 to that in 2003?
Your response must be concise. 1.02. What is the ratio of the Earning from trade(constant 2005 US) of Honduras in 2001 to that in 2003?
Your answer should be very brief. 0.84. What is the ratio of the Earning from trade(constant 2005 US) of Lebanon in 2001 to that in 2003?
Your response must be concise. 0.83. What is the ratio of the Earning from trade(constant 2005 US) in Cameroon in 2001 to that in 2004?
Make the answer very short. 0.94. What is the ratio of the Earning from trade(constant 2005 US) of Honduras in 2001 to that in 2004?
Your answer should be compact. 0.74. What is the ratio of the Earning from trade(constant 2005 US) of Lebanon in 2001 to that in 2004?
Give a very brief answer. 0.65. What is the ratio of the Earning from trade(constant 2005 US) in Cameroon in 2001 to that in 2005?
Provide a short and direct response. 0.92. What is the ratio of the Earning from trade(constant 2005 US) in Honduras in 2001 to that in 2005?
Your answer should be compact. 0.7. What is the ratio of the Earning from trade(constant 2005 US) of Lebanon in 2001 to that in 2005?
Provide a short and direct response. 0.61. What is the ratio of the Earning from trade(constant 2005 US) of Cameroon in 2001 to that in 2006?
Offer a terse response. 0.91. What is the ratio of the Earning from trade(constant 2005 US) in Honduras in 2001 to that in 2006?
Offer a very short reply. 0.69. What is the ratio of the Earning from trade(constant 2005 US) in Lebanon in 2001 to that in 2006?
Your response must be concise. 0.62. What is the ratio of the Earning from trade(constant 2005 US) in Cameroon in 2001 to that in 2007?
Keep it short and to the point. 0.86. What is the ratio of the Earning from trade(constant 2005 US) of Honduras in 2001 to that in 2007?
Your response must be concise. 0.67. What is the ratio of the Earning from trade(constant 2005 US) of Lebanon in 2001 to that in 2007?
Offer a very short reply. 0.55. What is the ratio of the Earning from trade(constant 2005 US) of Cameroon in 2001 to that in 2008?
Offer a terse response. 0.9. What is the ratio of the Earning from trade(constant 2005 US) in Honduras in 2001 to that in 2008?
Your answer should be compact. 0.67. What is the ratio of the Earning from trade(constant 2005 US) in Lebanon in 2001 to that in 2008?
Make the answer very short. 0.5. What is the ratio of the Earning from trade(constant 2005 US) of Honduras in 2002 to that in 2003?
Your response must be concise. 0.92. What is the ratio of the Earning from trade(constant 2005 US) of Lebanon in 2002 to that in 2003?
Make the answer very short. 0.93. What is the ratio of the Earning from trade(constant 2005 US) in Cameroon in 2002 to that in 2004?
Provide a short and direct response. 0.92. What is the ratio of the Earning from trade(constant 2005 US) of Honduras in 2002 to that in 2004?
Your answer should be compact. 0.81. What is the ratio of the Earning from trade(constant 2005 US) of Lebanon in 2002 to that in 2004?
Give a very brief answer. 0.74. What is the ratio of the Earning from trade(constant 2005 US) in Cameroon in 2002 to that in 2005?
Offer a very short reply. 0.91. What is the ratio of the Earning from trade(constant 2005 US) in Honduras in 2002 to that in 2005?
Make the answer very short. 0.77. What is the ratio of the Earning from trade(constant 2005 US) in Lebanon in 2002 to that in 2005?
Your response must be concise. 0.69. What is the ratio of the Earning from trade(constant 2005 US) of Cameroon in 2002 to that in 2006?
Provide a succinct answer. 0.89. What is the ratio of the Earning from trade(constant 2005 US) of Honduras in 2002 to that in 2006?
Provide a succinct answer. 0.76. What is the ratio of the Earning from trade(constant 2005 US) in Lebanon in 2002 to that in 2006?
Give a very brief answer. 0.7. What is the ratio of the Earning from trade(constant 2005 US) of Cameroon in 2002 to that in 2007?
Your response must be concise. 0.85. What is the ratio of the Earning from trade(constant 2005 US) of Honduras in 2002 to that in 2007?
Your answer should be very brief. 0.74. What is the ratio of the Earning from trade(constant 2005 US) in Lebanon in 2002 to that in 2007?
Make the answer very short. 0.62. What is the ratio of the Earning from trade(constant 2005 US) in Cameroon in 2002 to that in 2008?
Your answer should be very brief. 0.88. What is the ratio of the Earning from trade(constant 2005 US) in Honduras in 2002 to that in 2008?
Your answer should be very brief. 0.73. What is the ratio of the Earning from trade(constant 2005 US) of Lebanon in 2002 to that in 2008?
Your answer should be very brief. 0.56. What is the ratio of the Earning from trade(constant 2005 US) in Cameroon in 2003 to that in 2004?
Keep it short and to the point. 0.92. What is the ratio of the Earning from trade(constant 2005 US) of Honduras in 2003 to that in 2004?
Offer a very short reply. 0.88. What is the ratio of the Earning from trade(constant 2005 US) in Lebanon in 2003 to that in 2004?
Offer a very short reply. 0.79. What is the ratio of the Earning from trade(constant 2005 US) of Cameroon in 2003 to that in 2005?
Your response must be concise. 0.91. What is the ratio of the Earning from trade(constant 2005 US) in Honduras in 2003 to that in 2005?
Offer a very short reply. 0.84. What is the ratio of the Earning from trade(constant 2005 US) of Lebanon in 2003 to that in 2005?
Provide a succinct answer. 0.74. What is the ratio of the Earning from trade(constant 2005 US) of Cameroon in 2003 to that in 2006?
Your response must be concise. 0.89. What is the ratio of the Earning from trade(constant 2005 US) of Honduras in 2003 to that in 2006?
Make the answer very short. 0.83. What is the ratio of the Earning from trade(constant 2005 US) in Lebanon in 2003 to that in 2006?
Keep it short and to the point. 0.75. What is the ratio of the Earning from trade(constant 2005 US) in Cameroon in 2003 to that in 2007?
Offer a very short reply. 0.85. What is the ratio of the Earning from trade(constant 2005 US) of Honduras in 2003 to that in 2007?
Make the answer very short. 0.81. What is the ratio of the Earning from trade(constant 2005 US) in Lebanon in 2003 to that in 2007?
Your answer should be very brief. 0.66. What is the ratio of the Earning from trade(constant 2005 US) of Cameroon in 2003 to that in 2008?
Offer a very short reply. 0.88. What is the ratio of the Earning from trade(constant 2005 US) of Honduras in 2003 to that in 2008?
Ensure brevity in your answer.  0.8. What is the ratio of the Earning from trade(constant 2005 US) of Lebanon in 2003 to that in 2008?
Provide a succinct answer. 0.6. What is the ratio of the Earning from trade(constant 2005 US) in Cameroon in 2004 to that in 2005?
Your answer should be compact. 0.99. What is the ratio of the Earning from trade(constant 2005 US) in Honduras in 2004 to that in 2005?
Offer a very short reply. 0.95. What is the ratio of the Earning from trade(constant 2005 US) of Lebanon in 2004 to that in 2005?
Offer a very short reply. 0.94. What is the ratio of the Earning from trade(constant 2005 US) in Cameroon in 2004 to that in 2006?
Make the answer very short. 0.97. What is the ratio of the Earning from trade(constant 2005 US) in Honduras in 2004 to that in 2006?
Offer a very short reply. 0.94. What is the ratio of the Earning from trade(constant 2005 US) in Lebanon in 2004 to that in 2006?
Your answer should be compact. 0.96. What is the ratio of the Earning from trade(constant 2005 US) in Cameroon in 2004 to that in 2007?
Offer a very short reply. 0.92. What is the ratio of the Earning from trade(constant 2005 US) of Honduras in 2004 to that in 2007?
Your answer should be very brief. 0.91. What is the ratio of the Earning from trade(constant 2005 US) in Lebanon in 2004 to that in 2007?
Make the answer very short. 0.84. What is the ratio of the Earning from trade(constant 2005 US) of Cameroon in 2004 to that in 2008?
Give a very brief answer. 0.96. What is the ratio of the Earning from trade(constant 2005 US) in Honduras in 2004 to that in 2008?
Provide a short and direct response. 0.9. What is the ratio of the Earning from trade(constant 2005 US) of Lebanon in 2004 to that in 2008?
Keep it short and to the point. 0.76. What is the ratio of the Earning from trade(constant 2005 US) of Cameroon in 2005 to that in 2006?
Offer a very short reply. 0.99. What is the ratio of the Earning from trade(constant 2005 US) of Honduras in 2005 to that in 2006?
Keep it short and to the point. 0.98. What is the ratio of the Earning from trade(constant 2005 US) in Lebanon in 2005 to that in 2006?
Ensure brevity in your answer.  1.02. What is the ratio of the Earning from trade(constant 2005 US) of Cameroon in 2005 to that in 2007?
Offer a terse response. 0.94. What is the ratio of the Earning from trade(constant 2005 US) of Honduras in 2005 to that in 2007?
Your response must be concise. 0.96. What is the ratio of the Earning from trade(constant 2005 US) in Lebanon in 2005 to that in 2007?
Provide a short and direct response. 0.89. What is the ratio of the Earning from trade(constant 2005 US) of Cameroon in 2005 to that in 2008?
Your answer should be very brief. 0.97. What is the ratio of the Earning from trade(constant 2005 US) in Honduras in 2005 to that in 2008?
Make the answer very short. 0.95. What is the ratio of the Earning from trade(constant 2005 US) of Lebanon in 2005 to that in 2008?
Keep it short and to the point. 0.81. What is the ratio of the Earning from trade(constant 2005 US) of Cameroon in 2006 to that in 2007?
Keep it short and to the point. 0.95. What is the ratio of the Earning from trade(constant 2005 US) in Honduras in 2006 to that in 2007?
Your response must be concise. 0.98. What is the ratio of the Earning from trade(constant 2005 US) in Lebanon in 2006 to that in 2007?
Your answer should be very brief. 0.88. What is the ratio of the Earning from trade(constant 2005 US) of Cameroon in 2006 to that in 2008?
Provide a succinct answer. 0.99. What is the ratio of the Earning from trade(constant 2005 US) in Honduras in 2006 to that in 2008?
Provide a succinct answer. 0.97. What is the ratio of the Earning from trade(constant 2005 US) in Lebanon in 2006 to that in 2008?
Provide a short and direct response. 0.8. What is the ratio of the Earning from trade(constant 2005 US) in Cameroon in 2007 to that in 2008?
Your response must be concise. 1.04. What is the ratio of the Earning from trade(constant 2005 US) in Lebanon in 2007 to that in 2008?
Your response must be concise. 0.91. What is the difference between the highest and the second highest Earning from trade(constant 2005 US) in Cameroon?
Offer a terse response. 1.34e+08. What is the difference between the highest and the second highest Earning from trade(constant 2005 US) of Honduras?
Make the answer very short. 5.11e+07. What is the difference between the highest and the second highest Earning from trade(constant 2005 US) in Lebanon?
Your answer should be compact. 9.10e+08. What is the difference between the highest and the lowest Earning from trade(constant 2005 US) of Cameroon?
Keep it short and to the point. 5.50e+08. What is the difference between the highest and the lowest Earning from trade(constant 2005 US) of Honduras?
Offer a very short reply. 1.99e+09. What is the difference between the highest and the lowest Earning from trade(constant 2005 US) of Lebanon?
Your response must be concise. 4.97e+09. 